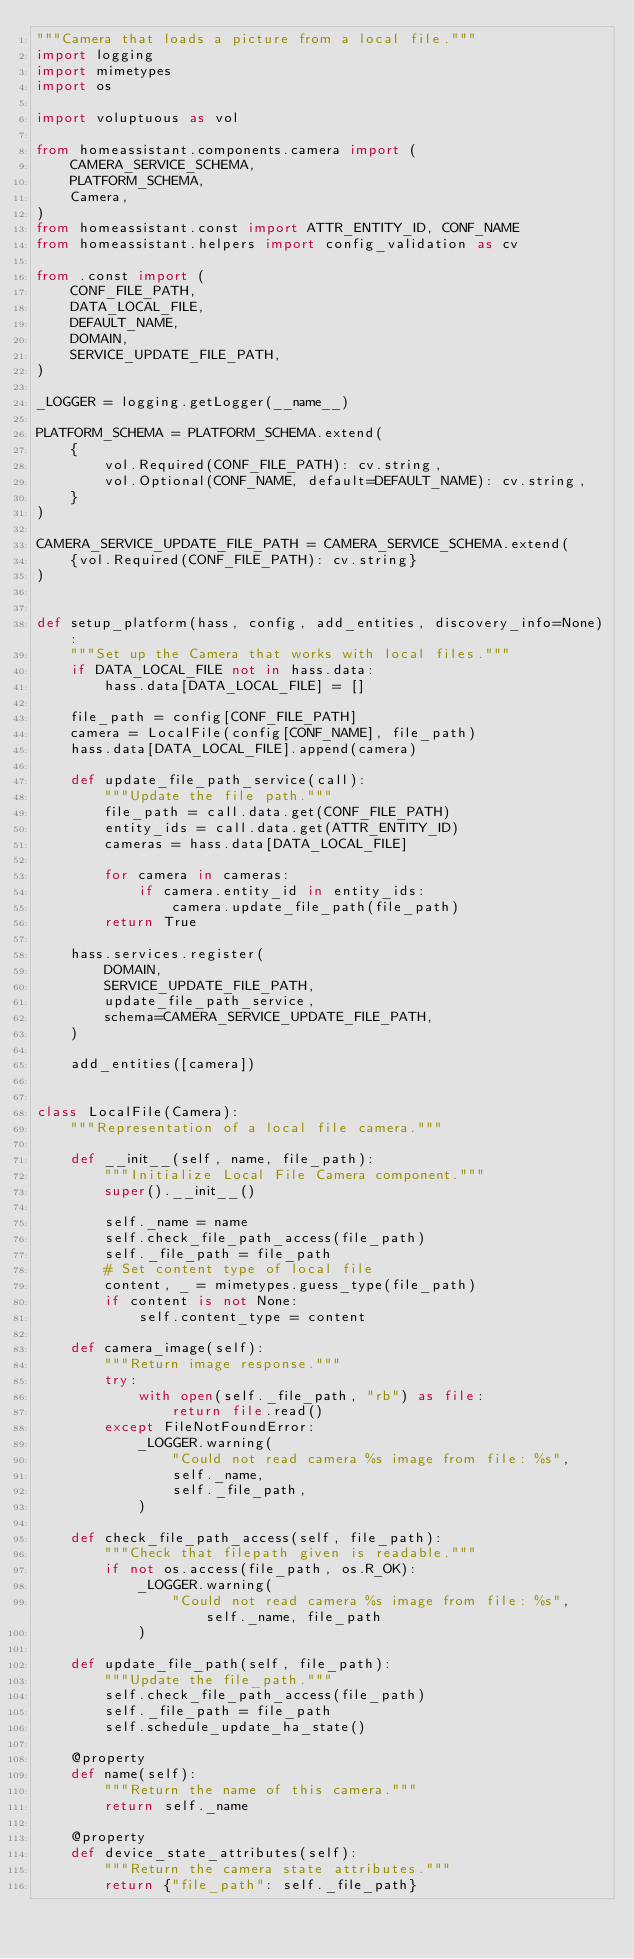Convert code to text. <code><loc_0><loc_0><loc_500><loc_500><_Python_>"""Camera that loads a picture from a local file."""
import logging
import mimetypes
import os

import voluptuous as vol

from homeassistant.components.camera import (
    CAMERA_SERVICE_SCHEMA,
    PLATFORM_SCHEMA,
    Camera,
)
from homeassistant.const import ATTR_ENTITY_ID, CONF_NAME
from homeassistant.helpers import config_validation as cv

from .const import (
    CONF_FILE_PATH,
    DATA_LOCAL_FILE,
    DEFAULT_NAME,
    DOMAIN,
    SERVICE_UPDATE_FILE_PATH,
)

_LOGGER = logging.getLogger(__name__)

PLATFORM_SCHEMA = PLATFORM_SCHEMA.extend(
    {
        vol.Required(CONF_FILE_PATH): cv.string,
        vol.Optional(CONF_NAME, default=DEFAULT_NAME): cv.string,
    }
)

CAMERA_SERVICE_UPDATE_FILE_PATH = CAMERA_SERVICE_SCHEMA.extend(
    {vol.Required(CONF_FILE_PATH): cv.string}
)


def setup_platform(hass, config, add_entities, discovery_info=None):
    """Set up the Camera that works with local files."""
    if DATA_LOCAL_FILE not in hass.data:
        hass.data[DATA_LOCAL_FILE] = []

    file_path = config[CONF_FILE_PATH]
    camera = LocalFile(config[CONF_NAME], file_path)
    hass.data[DATA_LOCAL_FILE].append(camera)

    def update_file_path_service(call):
        """Update the file path."""
        file_path = call.data.get(CONF_FILE_PATH)
        entity_ids = call.data.get(ATTR_ENTITY_ID)
        cameras = hass.data[DATA_LOCAL_FILE]

        for camera in cameras:
            if camera.entity_id in entity_ids:
                camera.update_file_path(file_path)
        return True

    hass.services.register(
        DOMAIN,
        SERVICE_UPDATE_FILE_PATH,
        update_file_path_service,
        schema=CAMERA_SERVICE_UPDATE_FILE_PATH,
    )

    add_entities([camera])


class LocalFile(Camera):
    """Representation of a local file camera."""

    def __init__(self, name, file_path):
        """Initialize Local File Camera component."""
        super().__init__()

        self._name = name
        self.check_file_path_access(file_path)
        self._file_path = file_path
        # Set content type of local file
        content, _ = mimetypes.guess_type(file_path)
        if content is not None:
            self.content_type = content

    def camera_image(self):
        """Return image response."""
        try:
            with open(self._file_path, "rb") as file:
                return file.read()
        except FileNotFoundError:
            _LOGGER.warning(
                "Could not read camera %s image from file: %s",
                self._name,
                self._file_path,
            )

    def check_file_path_access(self, file_path):
        """Check that filepath given is readable."""
        if not os.access(file_path, os.R_OK):
            _LOGGER.warning(
                "Could not read camera %s image from file: %s", self._name, file_path
            )

    def update_file_path(self, file_path):
        """Update the file_path."""
        self.check_file_path_access(file_path)
        self._file_path = file_path
        self.schedule_update_ha_state()

    @property
    def name(self):
        """Return the name of this camera."""
        return self._name

    @property
    def device_state_attributes(self):
        """Return the camera state attributes."""
        return {"file_path": self._file_path}
</code> 